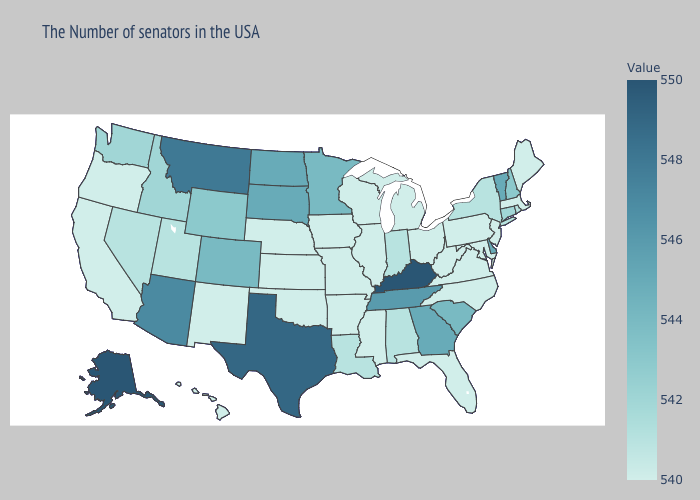Among the states that border Wisconsin , which have the highest value?
Give a very brief answer. Minnesota. Among the states that border Florida , does Georgia have the lowest value?
Keep it brief. No. Among the states that border Wisconsin , which have the highest value?
Quick response, please. Minnesota. Does Texas have a lower value than Indiana?
Give a very brief answer. No. 